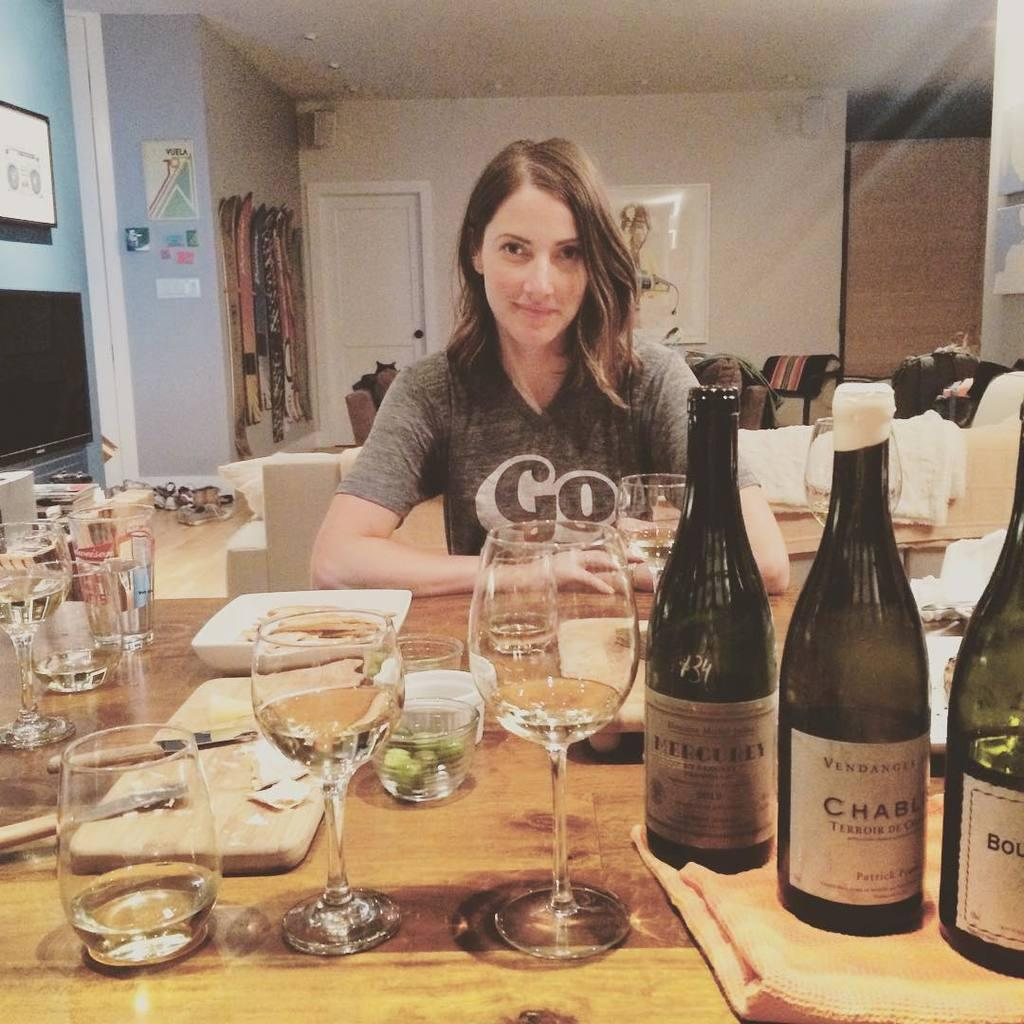<image>
Render a clear and concise summary of the photo. Satisfied woman with a shirt that says "Go" sitting across the table of 3 wine bottles, one which is Mercurey and is opened already. 